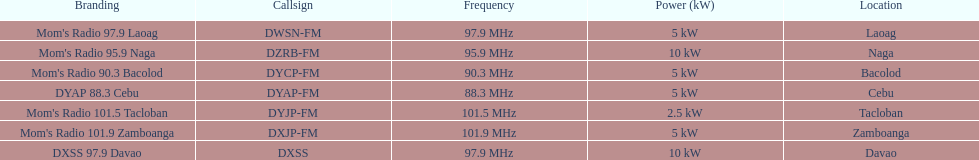What is the overall count of stations with frequencies exceeding 100 mhz? 2. 